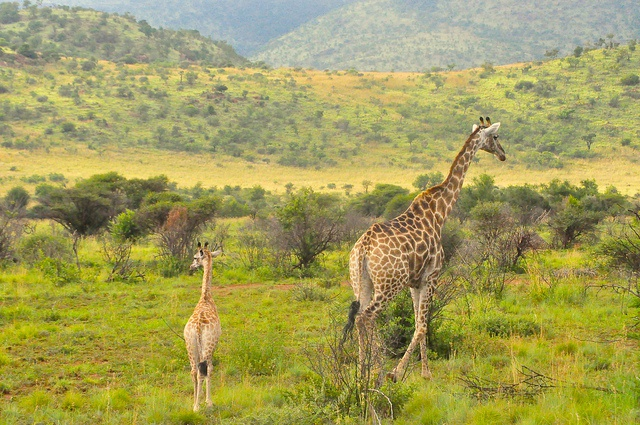Describe the objects in this image and their specific colors. I can see giraffe in lightblue, tan, olive, and gray tones and giraffe in lightblue and tan tones in this image. 